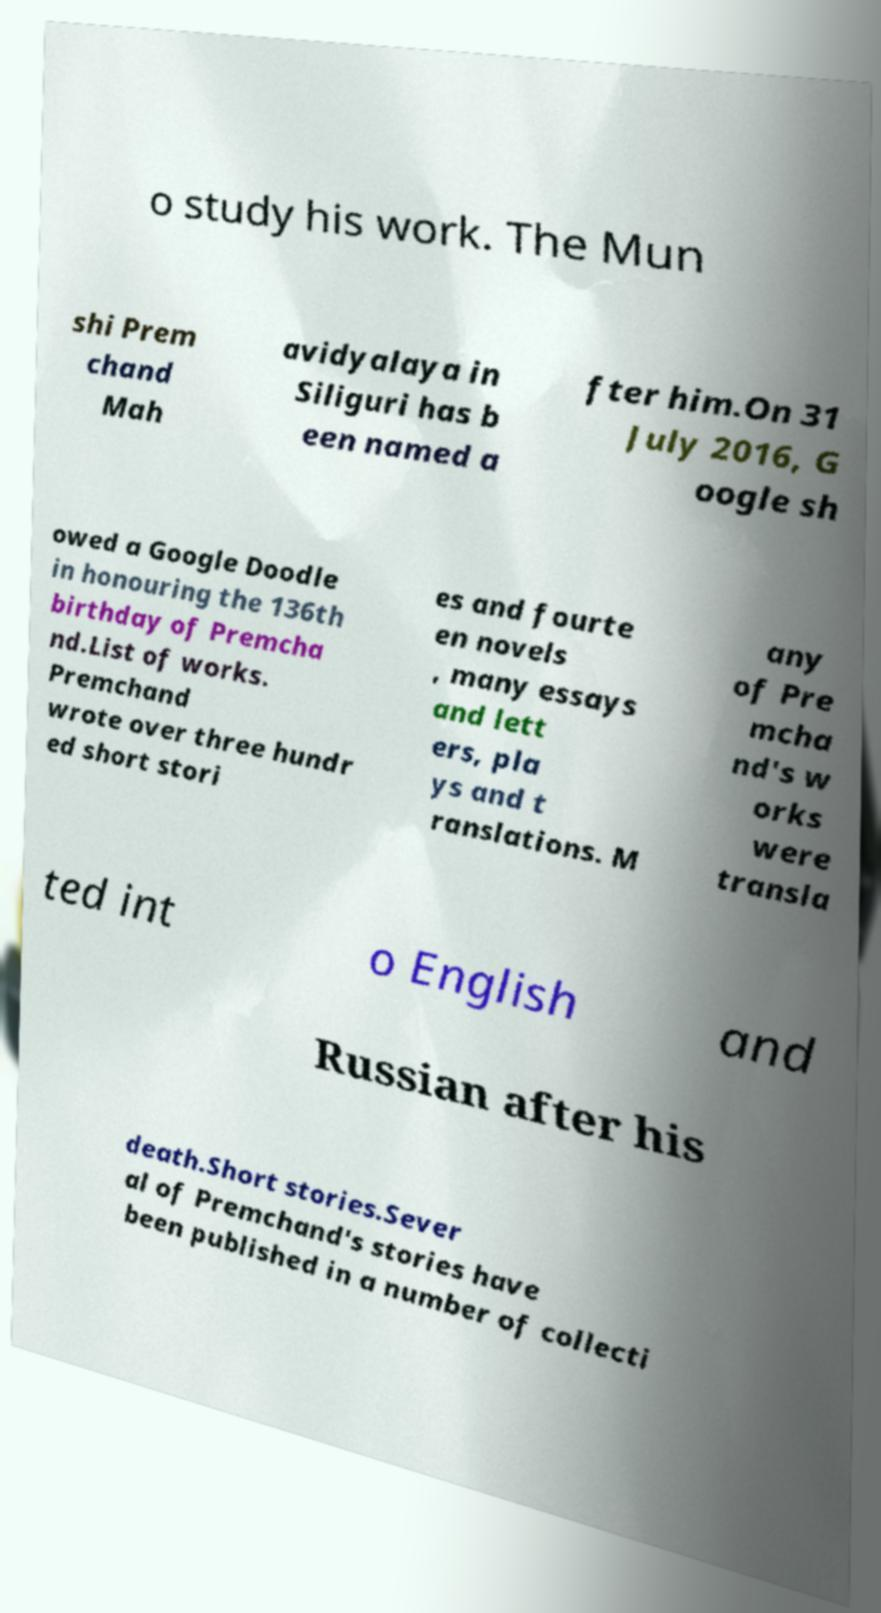Could you extract and type out the text from this image? o study his work. The Mun shi Prem chand Mah avidyalaya in Siliguri has b een named a fter him.On 31 July 2016, G oogle sh owed a Google Doodle in honouring the 136th birthday of Premcha nd.List of works. Premchand wrote over three hundr ed short stori es and fourte en novels , many essays and lett ers, pla ys and t ranslations. M any of Pre mcha nd's w orks were transla ted int o English and Russian after his death.Short stories.Sever al of Premchand's stories have been published in a number of collecti 